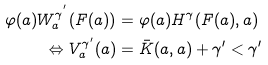Convert formula to latex. <formula><loc_0><loc_0><loc_500><loc_500>\varphi ( a ) W ^ { \gamma ^ { ^ { \prime } } } _ { a } ( F ( a ) ) & = \varphi ( a ) H ^ { \gamma } ( F ( a ) , a ) \\ \Leftrightarrow V _ { a } ^ { \gamma ^ { \prime } } ( a ) & = \bar { K } ( a , a ) + \gamma ^ { \prime } < \gamma ^ { \prime }</formula> 